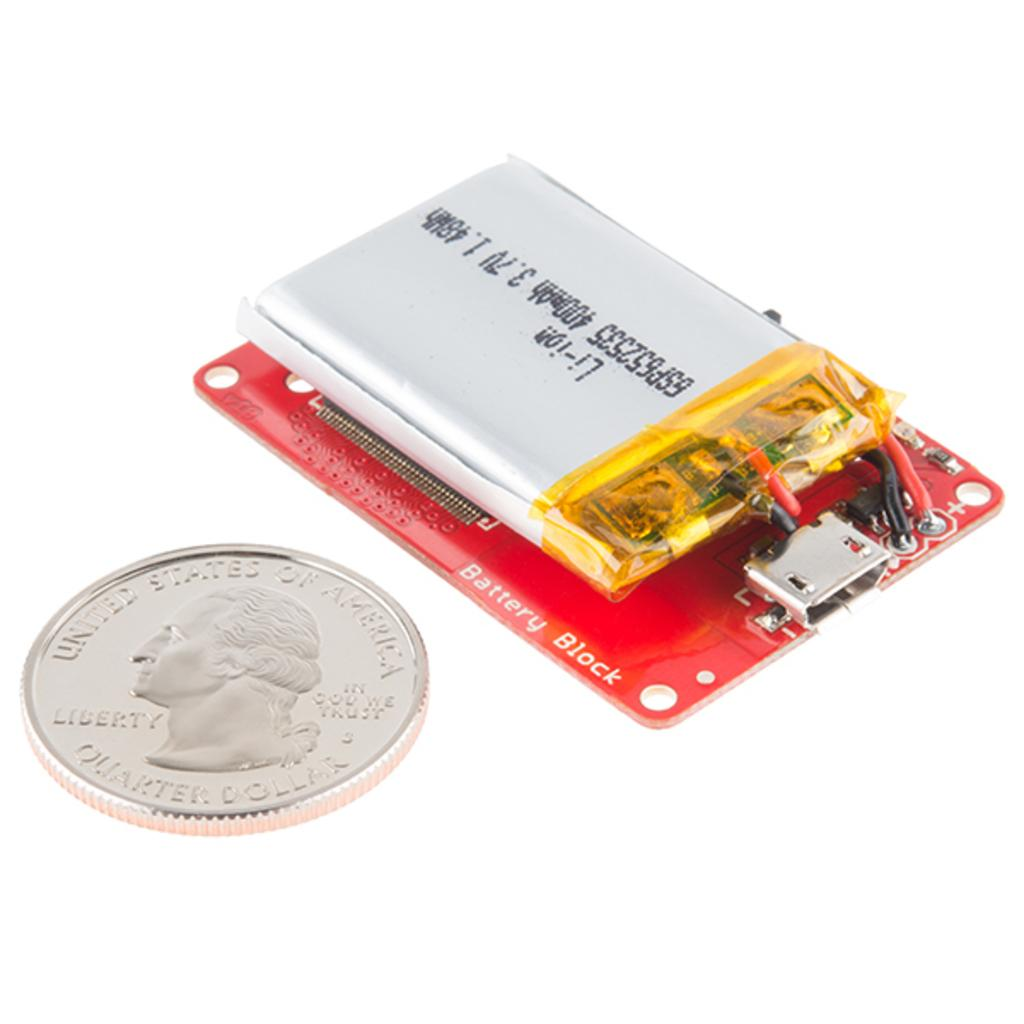What type of coin is visible in the image? There is a liberty coin in the image. What other object can be seen in the image besides the coin? There is a black object (battery) in the image. What color is the background of the image? The background of the image is white. How many grapes are being blown by the wind in the image? There are no grapes or wind present in the image. 